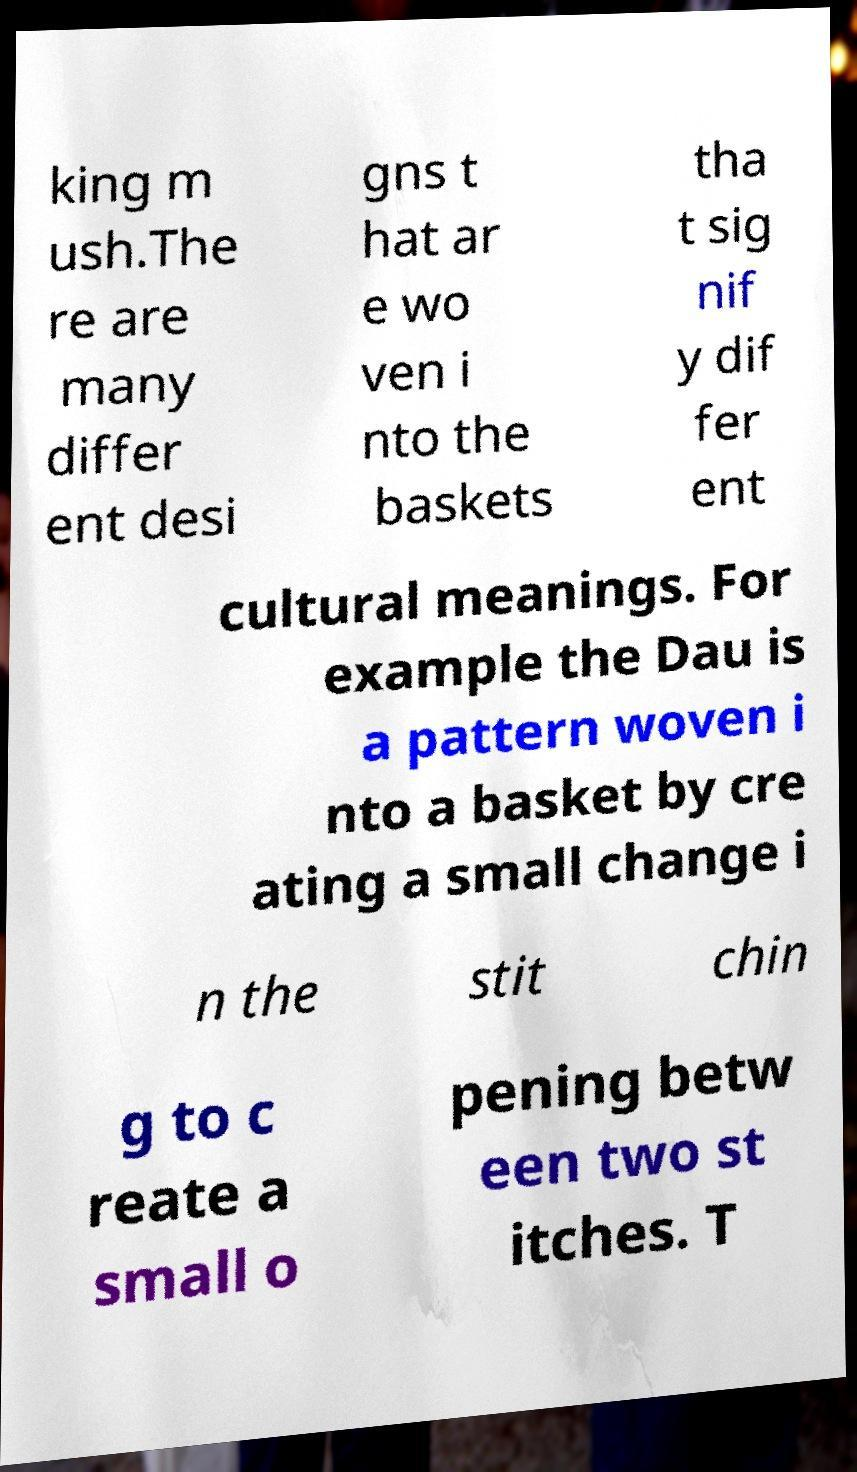I need the written content from this picture converted into text. Can you do that? king m ush.The re are many differ ent desi gns t hat ar e wo ven i nto the baskets tha t sig nif y dif fer ent cultural meanings. For example the Dau is a pattern woven i nto a basket by cre ating a small change i n the stit chin g to c reate a small o pening betw een two st itches. T 